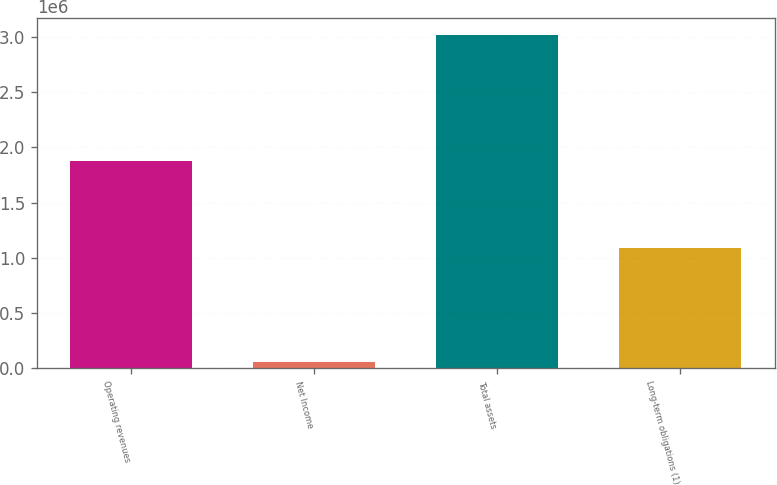<chart> <loc_0><loc_0><loc_500><loc_500><bar_chart><fcel>Operating revenues<fcel>Net Income<fcel>Total assets<fcel>Long-term obligations (1)<nl><fcel>1.88023e+06<fcel>54137<fcel>3.01987e+06<fcel>1.08568e+06<nl></chart> 